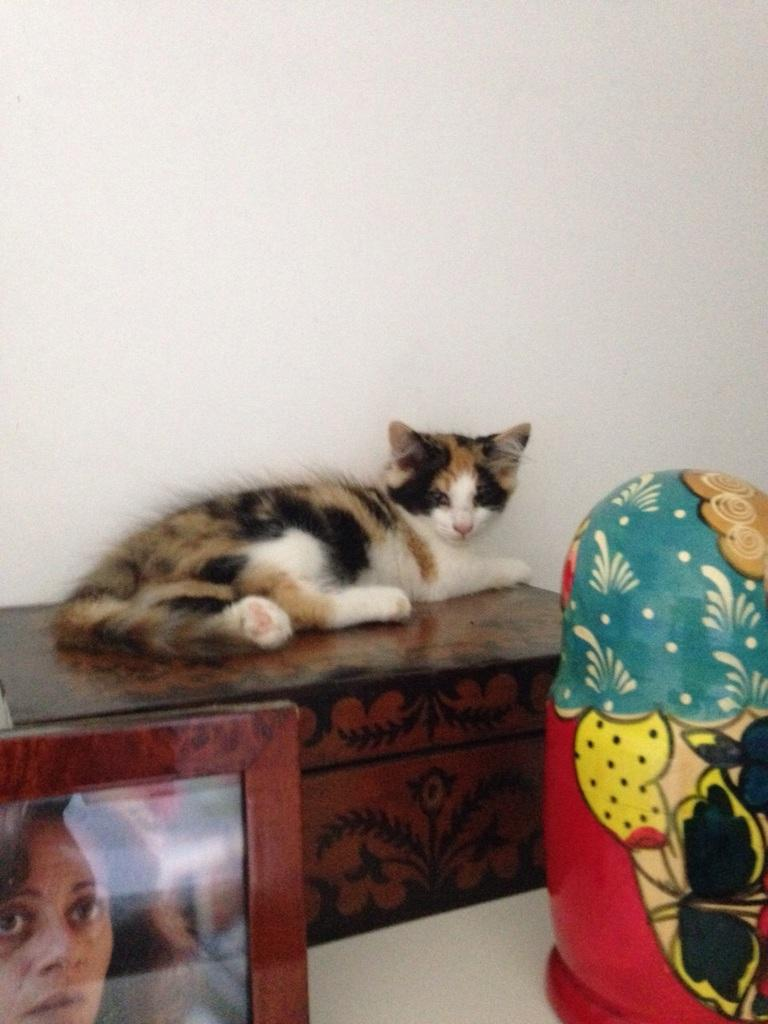What animal is present in the image? There is a cat in the image. Where is the cat located? The cat is on a box. What colors can be seen on the cat? The cat is white, black, and brown in color. What other objects can be seen in the image? There is a photo frame and a toy in the image. What is the color of the wall in the background? There is a white wall in the image. What type of meal is the cat eating in the image? There is no meal present in the image; the cat is on a box. Can you see a mitten in the image? There is no mitten present in the image. 